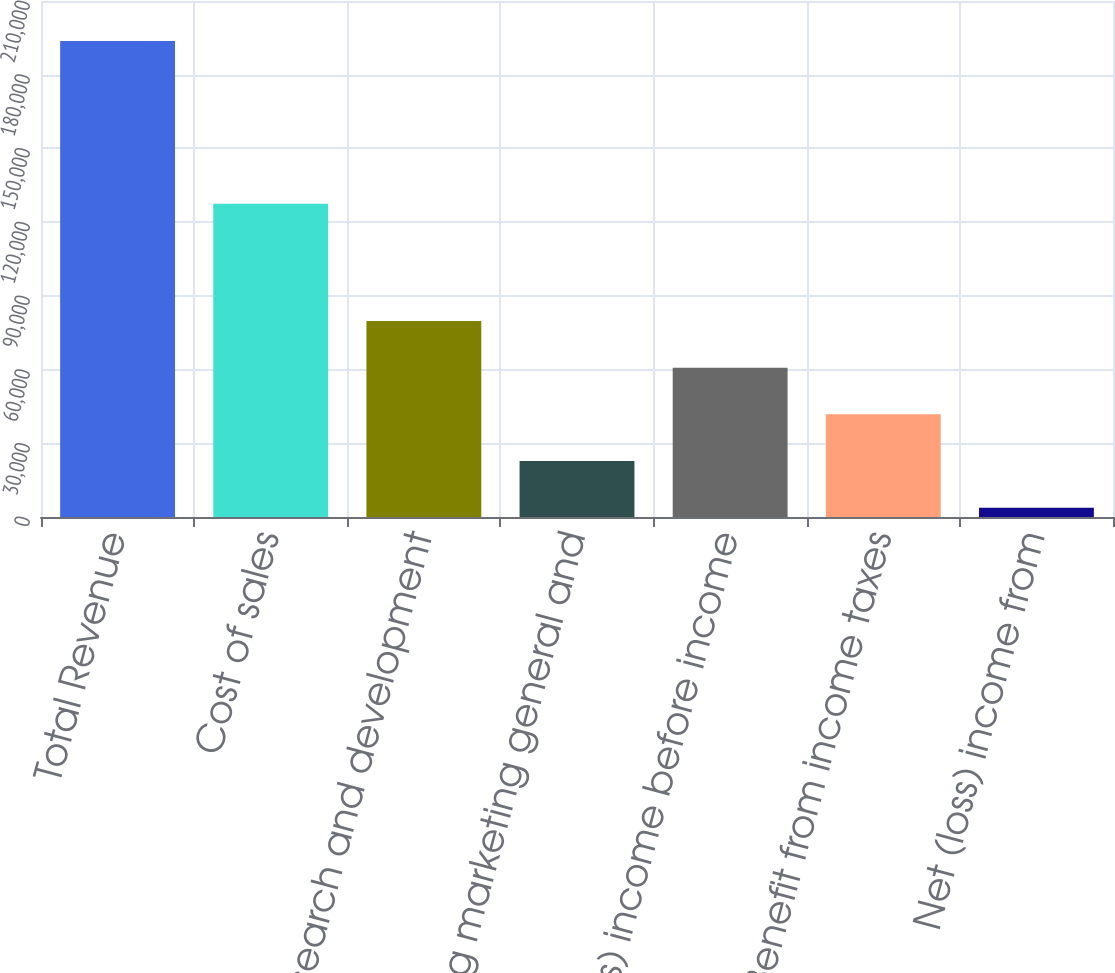Convert chart. <chart><loc_0><loc_0><loc_500><loc_500><bar_chart><fcel>Total Revenue<fcel>Cost of sales<fcel>Research and development<fcel>Selling marketing general and<fcel>(Loss) income before income<fcel>Benefit from income taxes<fcel>Net (loss) income from<nl><fcel>193710<fcel>127510<fcel>79756.8<fcel>22780.2<fcel>60764.6<fcel>41772.4<fcel>3788<nl></chart> 